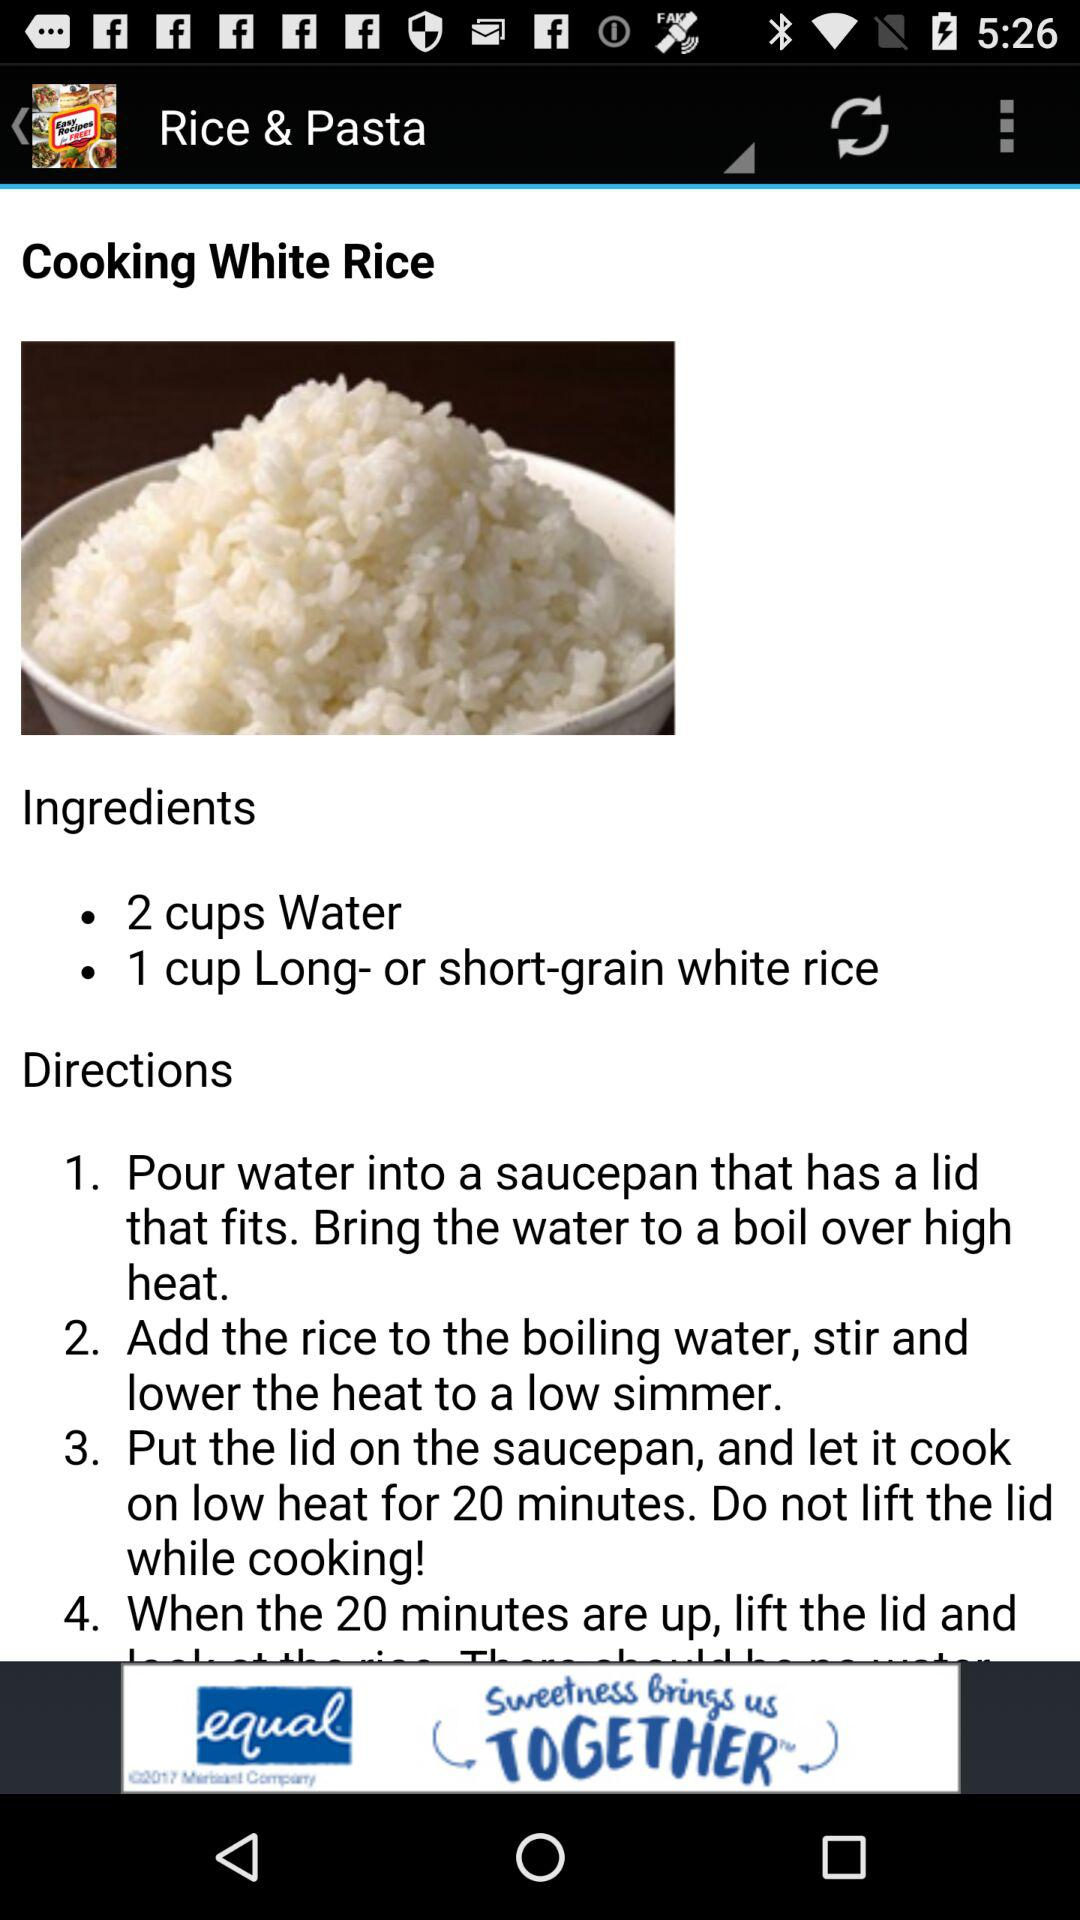What are the ingredients used in the recipe? The used ingredients are 2 cups of water and 1 cup of long- or short-grain white rice. 